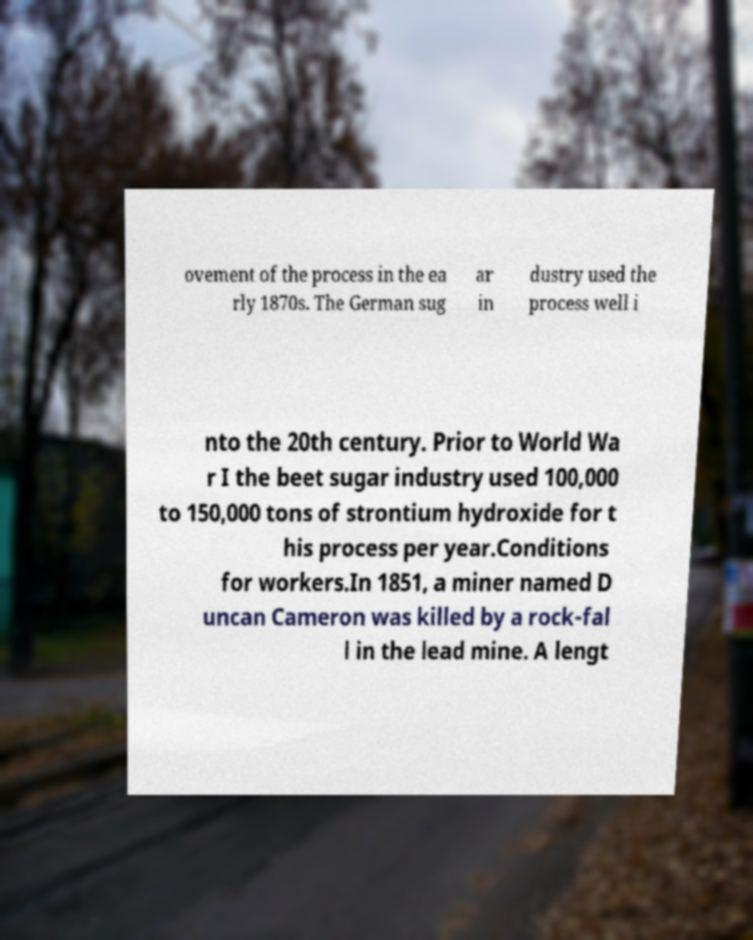Could you extract and type out the text from this image? ovement of the process in the ea rly 1870s. The German sug ar in dustry used the process well i nto the 20th century. Prior to World Wa r I the beet sugar industry used 100,000 to 150,000 tons of strontium hydroxide for t his process per year.Conditions for workers.In 1851, a miner named D uncan Cameron was killed by a rock-fal l in the lead mine. A lengt 